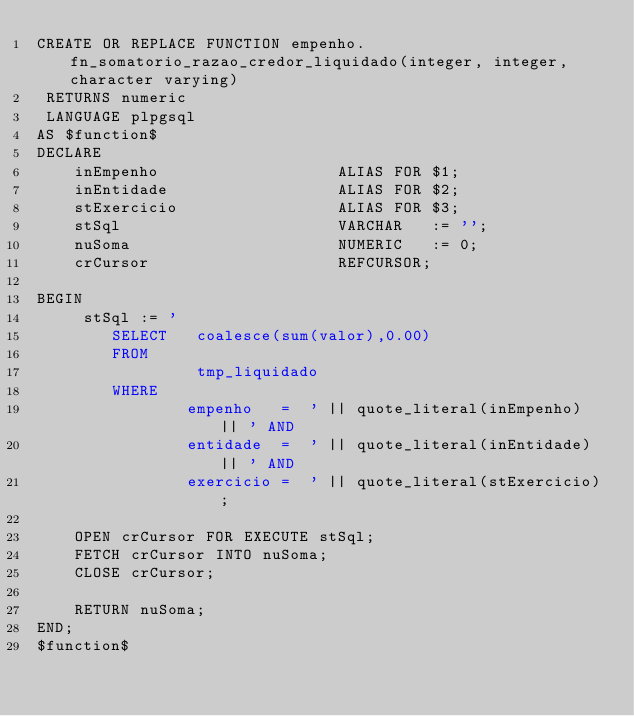Convert code to text. <code><loc_0><loc_0><loc_500><loc_500><_SQL_>CREATE OR REPLACE FUNCTION empenho.fn_somatorio_razao_credor_liquidado(integer, integer, character varying)
 RETURNS numeric
 LANGUAGE plpgsql
AS $function$
DECLARE
    inEmpenho                   ALIAS FOR $1;
    inEntidade                  ALIAS FOR $2;
    stExercicio                 ALIAS FOR $3;
    stSql                       VARCHAR   := '';
    nuSoma                      NUMERIC   := 0;
    crCursor                    REFCURSOR;

BEGIN
     stSql := '
        SELECT   coalesce(sum(valor),0.00)
        FROM
                 tmp_liquidado
        WHERE
                empenho   =  ' || quote_literal(inEmpenho) || ' AND
                entidade  =  ' || quote_literal(inEntidade) || ' AND
                exercicio =  ' || quote_literal(stExercicio);

    OPEN crCursor FOR EXECUTE stSql;
    FETCH crCursor INTO nuSoma;
    CLOSE crCursor;

    RETURN nuSoma;
END;
$function$
</code> 